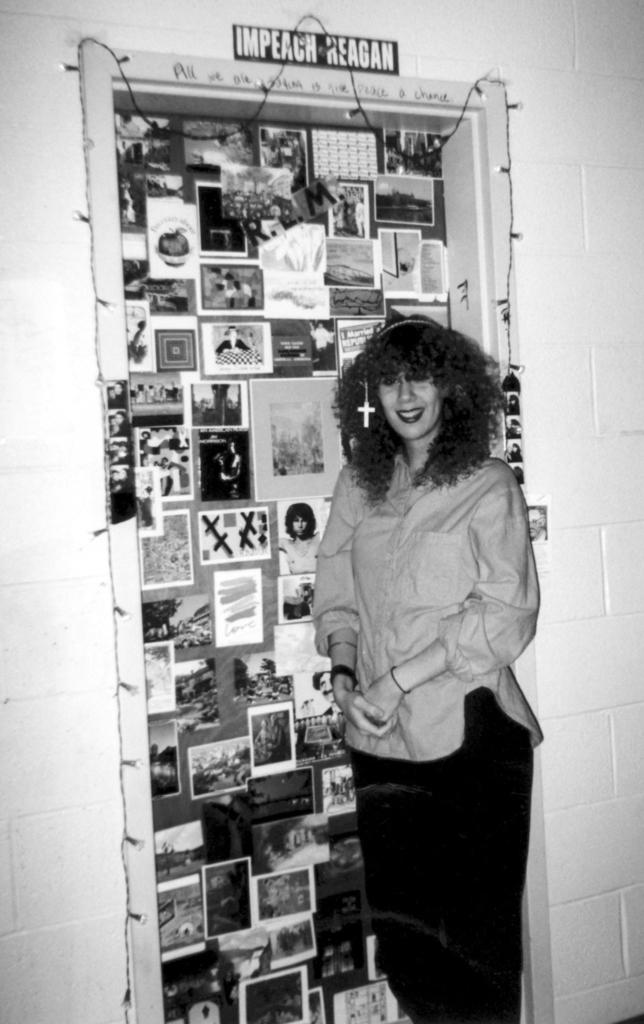What is the color scheme of the image? The image is black and white. Can you describe the person in the image? There is a person in the image. What is on the wall in the image? There is a wall with posters in the image. What can be seen illuminating the scene? There are lights visible in the image. What type of information is present in the image? There is some text present in the image. What type of pen is the person using to draw attention to the library in the image? There is no pen or library present in the image. 